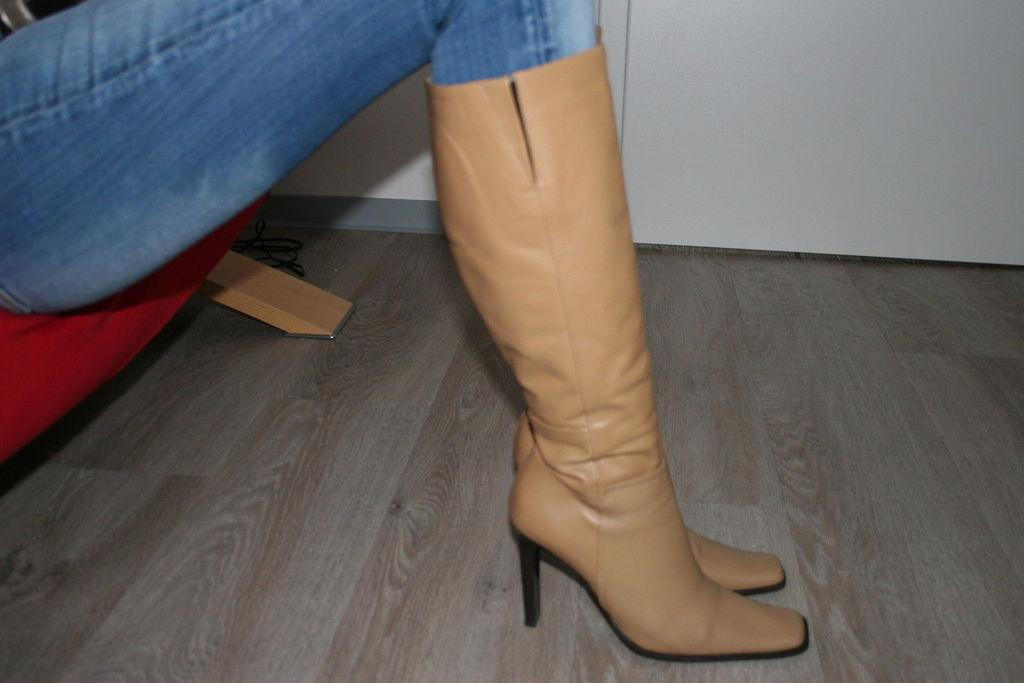What can be seen in the image related to a person's legs? There are a person's legs with boots in the image. What type of object is present in the image that has a red color? There is a red color object that looks like a chair in the image. What type of flooring is visible in the image? There is a wooden floor in the image. What color is the wall visible in the background of the image? There is a white color wall in the background of the image. In which direction is the person's eye looking in the image? There is no person's eye visible in the image, only their legs with boots. What other things can be seen in the image besides the red object and the wooden floor? The provided facts do not mention any other things in the image besides the person's legs with boots, the red object that looks like a chair, the wooden floor, and the white wall in the background. 